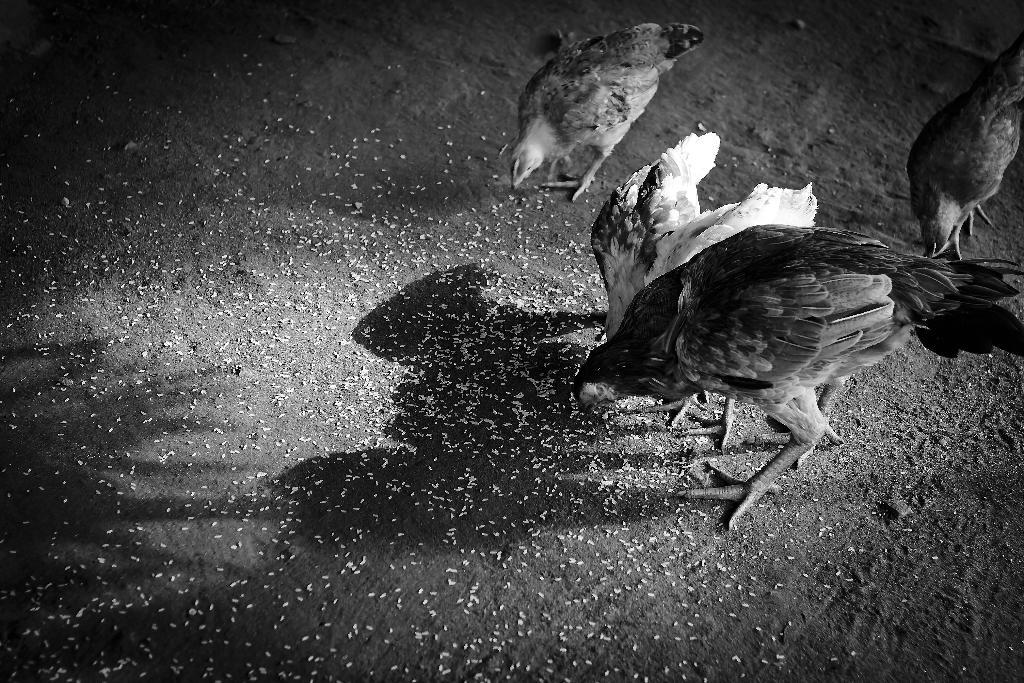What is the color scheme of the image? The image is black and white. What animals are present in the image? There are hens in the image. What are the hens doing in the image? The hens are eating food grains. Where are the food grains located in the image? The food grains are on the ground. What type of doll is sitting next to the hens in the image? There is no doll present in the image; it only features hens eating food grains on the ground. 